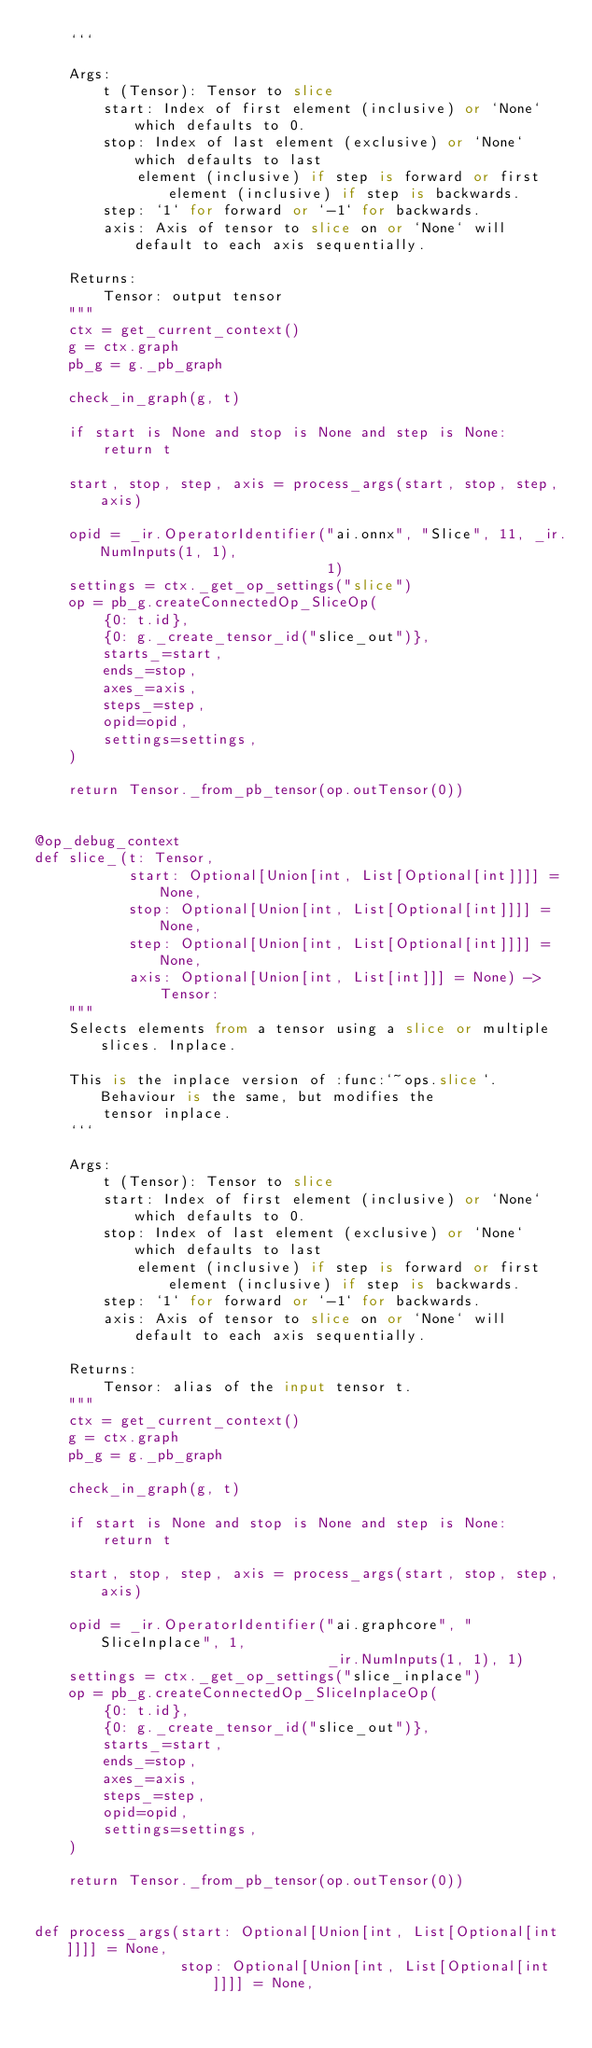<code> <loc_0><loc_0><loc_500><loc_500><_Python_>    ```

    Args:
        t (Tensor): Tensor to slice
        start: Index of first element (inclusive) or `None` which defaults to 0.
        stop: Index of last element (exclusive) or `None` which defaults to last
            element (inclusive) if step is forward or first element (inclusive) if step is backwards.
        step: `1` for forward or `-1` for backwards.
        axis: Axis of tensor to slice on or `None` will default to each axis sequentially.

    Returns:
        Tensor: output tensor
    """
    ctx = get_current_context()
    g = ctx.graph
    pb_g = g._pb_graph

    check_in_graph(g, t)

    if start is None and stop is None and step is None:
        return t

    start, stop, step, axis = process_args(start, stop, step, axis)

    opid = _ir.OperatorIdentifier("ai.onnx", "Slice", 11, _ir.NumInputs(1, 1),
                                  1)
    settings = ctx._get_op_settings("slice")
    op = pb_g.createConnectedOp_SliceOp(
        {0: t.id},
        {0: g._create_tensor_id("slice_out")},
        starts_=start,
        ends_=stop,
        axes_=axis,
        steps_=step,
        opid=opid,
        settings=settings,
    )

    return Tensor._from_pb_tensor(op.outTensor(0))


@op_debug_context
def slice_(t: Tensor,
           start: Optional[Union[int, List[Optional[int]]]] = None,
           stop: Optional[Union[int, List[Optional[int]]]] = None,
           step: Optional[Union[int, List[Optional[int]]]] = None,
           axis: Optional[Union[int, List[int]]] = None) -> Tensor:
    """
    Selects elements from a tensor using a slice or multiple slices. Inplace.

    This is the inplace version of :func:`~ops.slice`. Behaviour is the same, but modifies the
        tensor inplace.
    ```

    Args:
        t (Tensor): Tensor to slice
        start: Index of first element (inclusive) or `None` which defaults to 0.
        stop: Index of last element (exclusive) or `None` which defaults to last
            element (inclusive) if step is forward or first element (inclusive) if step is backwards.
        step: `1` for forward or `-1` for backwards.
        axis: Axis of tensor to slice on or `None` will default to each axis sequentially.

    Returns:
        Tensor: alias of the input tensor t.
    """
    ctx = get_current_context()
    g = ctx.graph
    pb_g = g._pb_graph

    check_in_graph(g, t)

    if start is None and stop is None and step is None:
        return t

    start, stop, step, axis = process_args(start, stop, step, axis)

    opid = _ir.OperatorIdentifier("ai.graphcore", "SliceInplace", 1,
                                  _ir.NumInputs(1, 1), 1)
    settings = ctx._get_op_settings("slice_inplace")
    op = pb_g.createConnectedOp_SliceInplaceOp(
        {0: t.id},
        {0: g._create_tensor_id("slice_out")},
        starts_=start,
        ends_=stop,
        axes_=axis,
        steps_=step,
        opid=opid,
        settings=settings,
    )

    return Tensor._from_pb_tensor(op.outTensor(0))


def process_args(start: Optional[Union[int, List[Optional[int]]]] = None,
                 stop: Optional[Union[int, List[Optional[int]]]] = None,</code> 